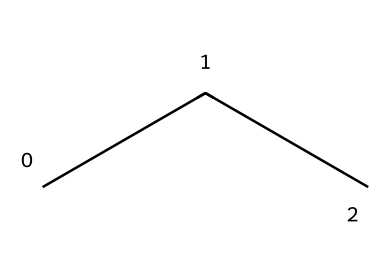What is the name of this hydrocarbon? The SMILES representation "CCC" denotes a straight-chain alkane with three carbon atoms, which is known as propane.
Answer: propane How many carbon atoms are in propane? The SMILES "CCC" indicates there are three carbon atoms in the structure. Each "C" represents one carbon atom, totaling three.
Answer: 3 What is the type of bonding in propane? Propane consists entirely of single covalent bonds between carbon atoms and between carbon and hydrogen atoms, characteristic of alkanes.
Answer: single What is the molecular formula of propane? Propane has three carbon (C) atoms and eight hydrogen (H) atoms, resulting in the molecular formula C3H8.
Answer: C3H8 How many hydrogen atoms are associated with each carbon atom in propane? In propane, the formula C3H8 shows that for every carbon atom, there are, on average, about 2.67 hydrogen atoms; however, each terminal carbon has three hydrogen atoms, and the middle carbon has two.
Answer: 3 Why is propane used in outdoor heaters for basketball courts? Propane is used in outdoor heaters because it burns cleanly and provides efficient heating, producing a lot of heat energy due to complete combustion.
Answer: efficient heating Is propane a saturated or unsaturated hydrocarbon? Propane is saturated because all carbon atoms are connected with single bonds, with no double or triple bonds present.
Answer: saturated 